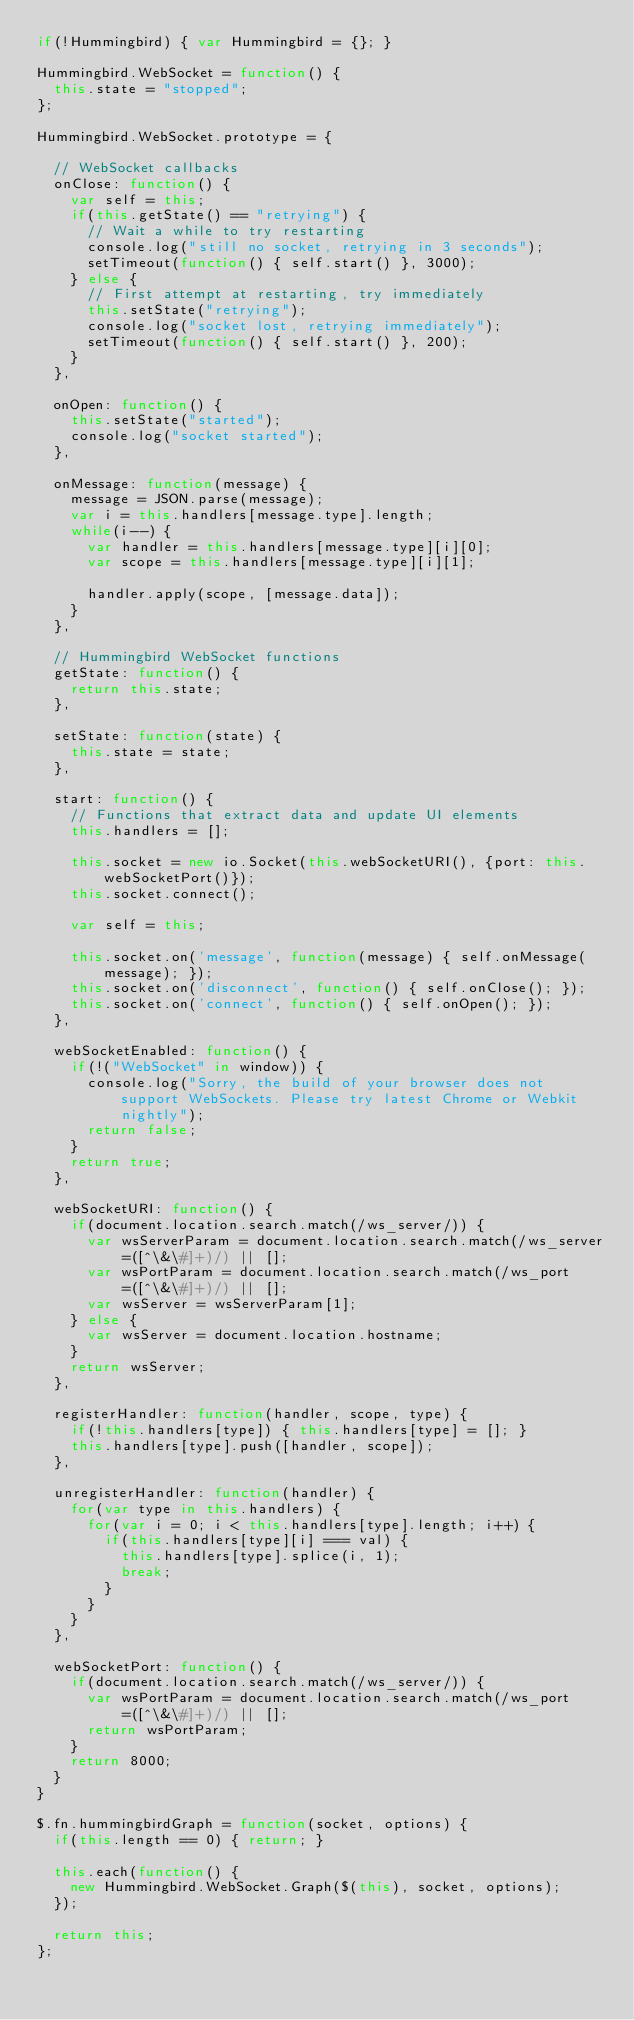<code> <loc_0><loc_0><loc_500><loc_500><_JavaScript_>if(!Hummingbird) { var Hummingbird = {}; }

Hummingbird.WebSocket = function() {
  this.state = "stopped";
};

Hummingbird.WebSocket.prototype = {

  // WebSocket callbacks
  onClose: function() {
    var self = this;
    if(this.getState() == "retrying") {
      // Wait a while to try restarting
      console.log("still no socket, retrying in 3 seconds");
      setTimeout(function() { self.start() }, 3000);
    } else {
      // First attempt at restarting, try immediately
      this.setState("retrying");
      console.log("socket lost, retrying immediately");
      setTimeout(function() { self.start() }, 200);
    }
  },

  onOpen: function() {
    this.setState("started");
    console.log("socket started");
  },

  onMessage: function(message) {
    message = JSON.parse(message);
    var i = this.handlers[message.type].length;
    while(i--) {
      var handler = this.handlers[message.type][i][0];
      var scope = this.handlers[message.type][i][1];

      handler.apply(scope, [message.data]);
    }
  },

  // Hummingbird WebSocket functions
  getState: function() {
    return this.state;
  },

  setState: function(state) {
    this.state = state;
  },

  start: function() {
    // Functions that extract data and update UI elements
    this.handlers = [];

    this.socket = new io.Socket(this.webSocketURI(), {port: this.webSocketPort()});
    this.socket.connect();

    var self = this;

    this.socket.on('message', function(message) { self.onMessage(message); });
    this.socket.on('disconnect', function() { self.onClose(); });
    this.socket.on('connect', function() { self.onOpen(); });
  },

  webSocketEnabled: function() {
    if(!("WebSocket" in window)) {
      console.log("Sorry, the build of your browser does not support WebSockets. Please try latest Chrome or Webkit nightly");
      return false;
    }
    return true;
  },

  webSocketURI: function() {
    if(document.location.search.match(/ws_server/)) {
      var wsServerParam = document.location.search.match(/ws_server=([^\&\#]+)/) || [];
      var wsPortParam = document.location.search.match(/ws_port=([^\&\#]+)/) || [];
      var wsServer = wsServerParam[1];
    } else {
      var wsServer = document.location.hostname;
    }
    return wsServer;
  },

  registerHandler: function(handler, scope, type) {
    if(!this.handlers[type]) { this.handlers[type] = []; }
    this.handlers[type].push([handler, scope]);
  },

  unregisterHandler: function(handler) {
    for(var type in this.handlers) {
      for(var i = 0; i < this.handlers[type].length; i++) {
        if(this.handlers[type][i] === val) {
          this.handlers[type].splice(i, 1);
          break;
        }
      }
    }
  },

  webSocketPort: function() {
    if(document.location.search.match(/ws_server/)) {
      var wsPortParam = document.location.search.match(/ws_port=([^\&\#]+)/) || [];
      return wsPortParam;
    }
    return 8000;
  }
}

$.fn.hummingbirdGraph = function(socket, options) {
  if(this.length == 0) { return; }

  this.each(function() {
    new Hummingbird.WebSocket.Graph($(this), socket, options);
  });

  return this;
};
</code> 